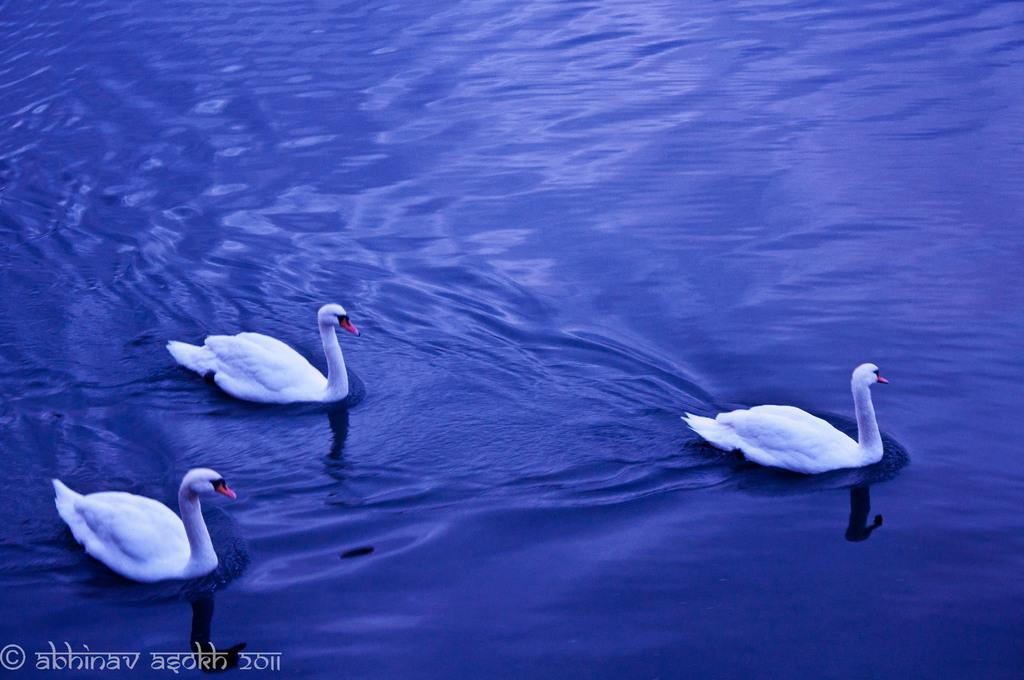What is the main subject of the photograph in the image? The main subject of the photograph in the image is water. What color is the water in the image? The water is blue in color. Are there any animals visible in the image? Yes, there are three ducks in the image. What color are the ducks in the image? The ducks are white in color. What type of observation can be made about the vacation destination in the image? There is no information about a vacation destination in the image; it features a photograph of water with three white ducks. What boundary is visible in the image? There is no boundary visible in the image; it features a photograph of water with three white ducks. 